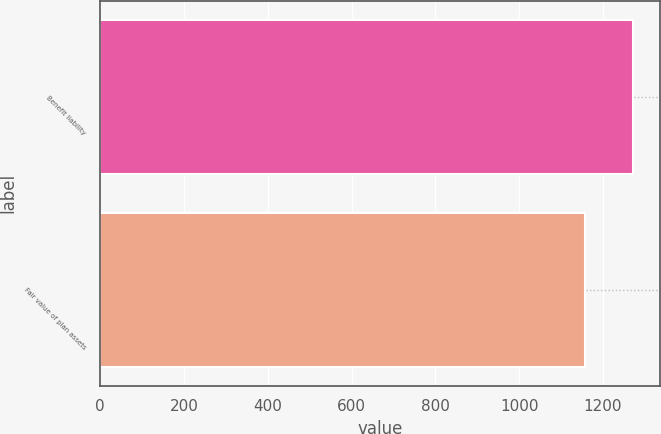<chart> <loc_0><loc_0><loc_500><loc_500><bar_chart><fcel>Benefit liability<fcel>Fair value of plan assets<nl><fcel>1273<fcel>1158<nl></chart> 